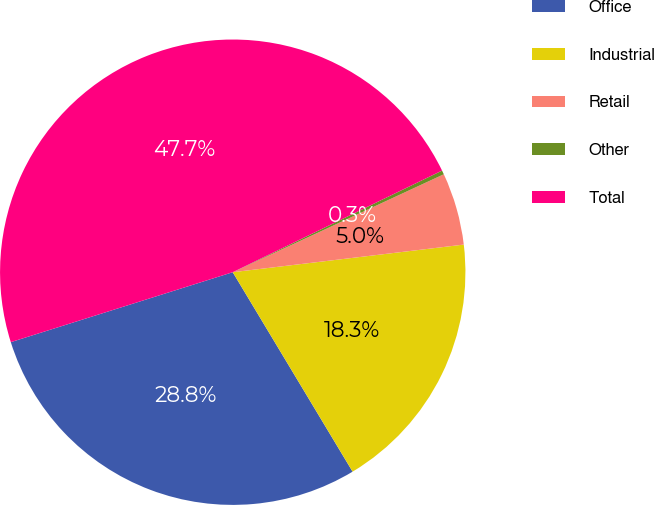Convert chart. <chart><loc_0><loc_0><loc_500><loc_500><pie_chart><fcel>Office<fcel>Industrial<fcel>Retail<fcel>Other<fcel>Total<nl><fcel>28.75%<fcel>18.28%<fcel>5.02%<fcel>0.28%<fcel>47.66%<nl></chart> 